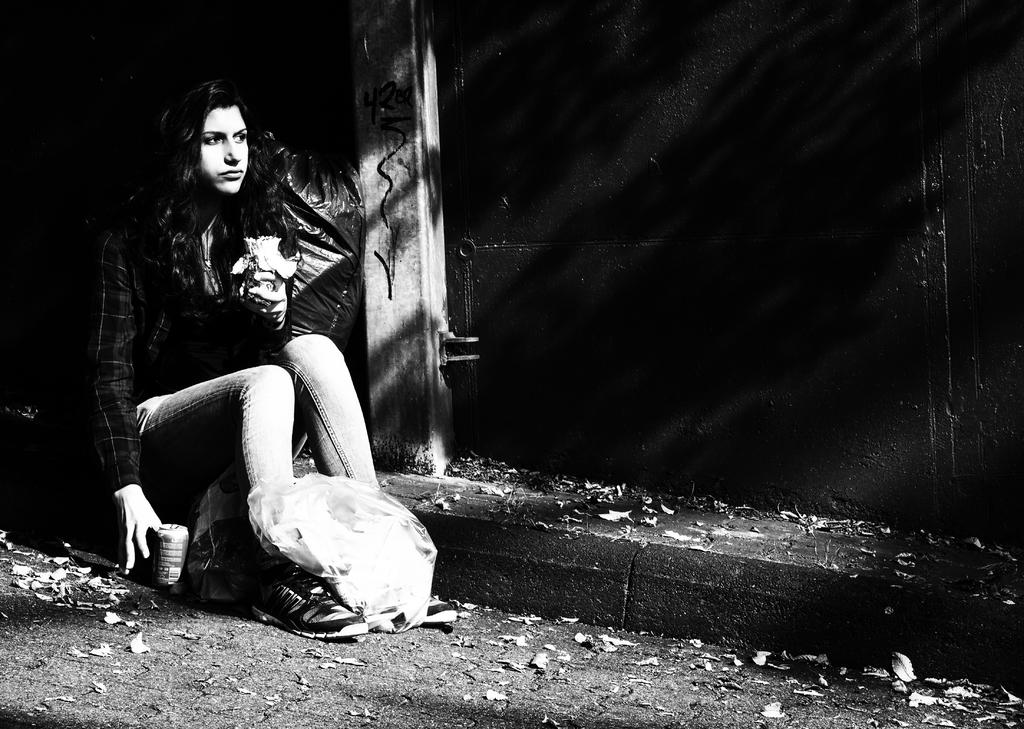Who is the main subject in the image? There is a woman in the image. What is the woman doing in the image? The woman is sitting on the ground. Can you describe the lighting in the image? The image is dark. What type of list is the woman holding in the image? There is no list present in the image; the woman is simply sitting on the ground. 